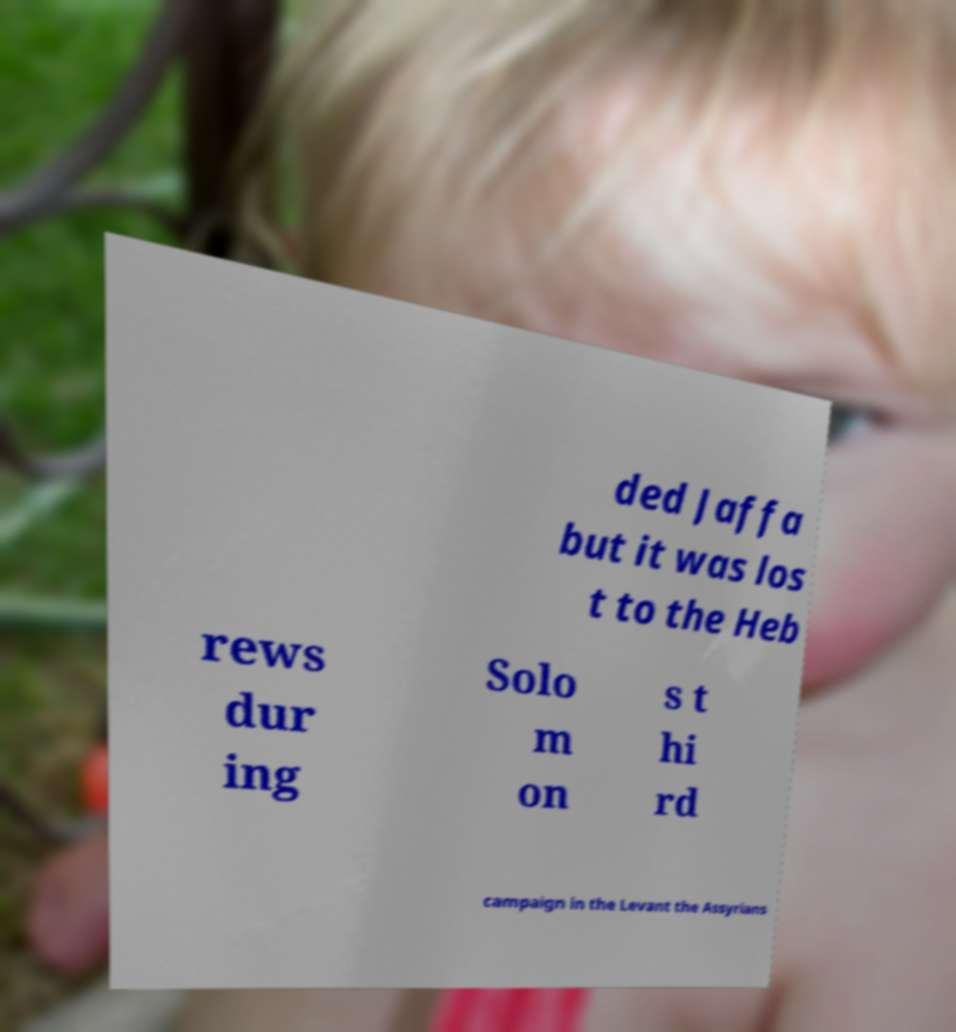What messages or text are displayed in this image? I need them in a readable, typed format. ded Jaffa but it was los t to the Heb rews dur ing Solo m on s t hi rd campaign in the Levant the Assyrians 